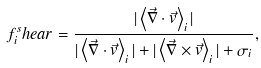<formula> <loc_0><loc_0><loc_500><loc_500>f _ { i } ^ { s } h e a r = \frac { | \left < \vec { \nabla } \cdot \vec { v } \right > _ { i } | } { | \left < \vec { \nabla } \cdot \vec { v } \right > _ { i } | + | \left < \vec { \nabla } \times \vec { v } \right > _ { i } | + \sigma _ { i } } ,</formula> 